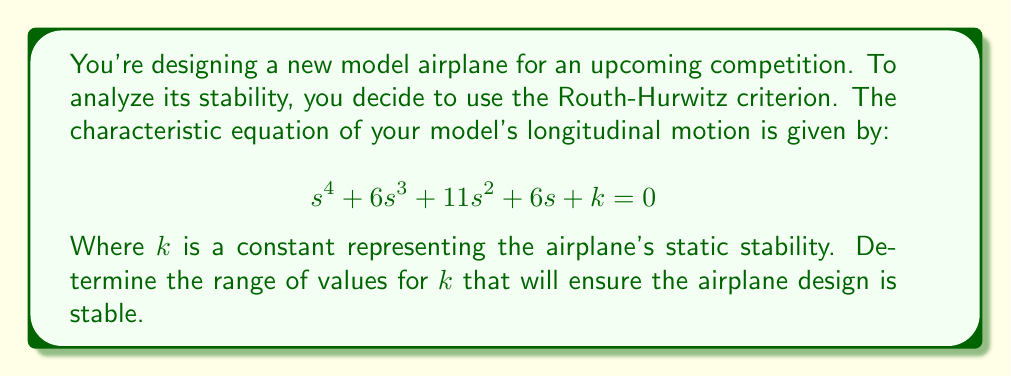Help me with this question. To solve this problem, we'll use the Routh-Hurwitz criterion:

1) First, construct the Routh array:

   $$\begin{array}{c|c c}
   s^4 & 1 & 11 & k \\
   s^3 & 6 & 6 & 0 \\
   s^2 & a & b & 0 \\
   s^1 & c & 0 & 0 \\
   s^0 & k & 0 & 0
   \end{array}$$

2) Calculate $a$:
   $$a = \frac{6 \cdot 11 - 1 \cdot 6}{6} = 10$$

3) Calculate $b$:
   $$b = \frac{6k - 1 \cdot 0}{6} = k$$

4) Calculate $c$:
   $$c = \frac{10 \cdot 6 - 6k}{10} = 6 - \frac{3k}{5}$$

5) For stability, all elements in the first column of the Routh array must be positive. This gives us the following conditions:

   $1 > 0$ (always true)
   $6 > 0$ (always true)
   $10 > 0$ (always true)
   $6 - \frac{3k}{5} > 0$
   $k > 0$

6) Solving the inequality $6 - \frac{3k}{5} > 0$:
   $$6 - \frac{3k}{5} > 0$$
   $$6 > \frac{3k}{5}$$
   $$30 > 3k$$
   $$10 > k$$

7) Combining this with $k > 0$, we get:
   $$0 < k < 10$$

Therefore, for stability, $k$ must be between 0 and 10, not including 0 or 10.
Answer: $0 < k < 10$ 